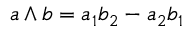Convert formula to latex. <formula><loc_0><loc_0><loc_500><loc_500>a \wedge b = a _ { 1 } b _ { 2 } - a _ { 2 } b _ { 1 }</formula> 